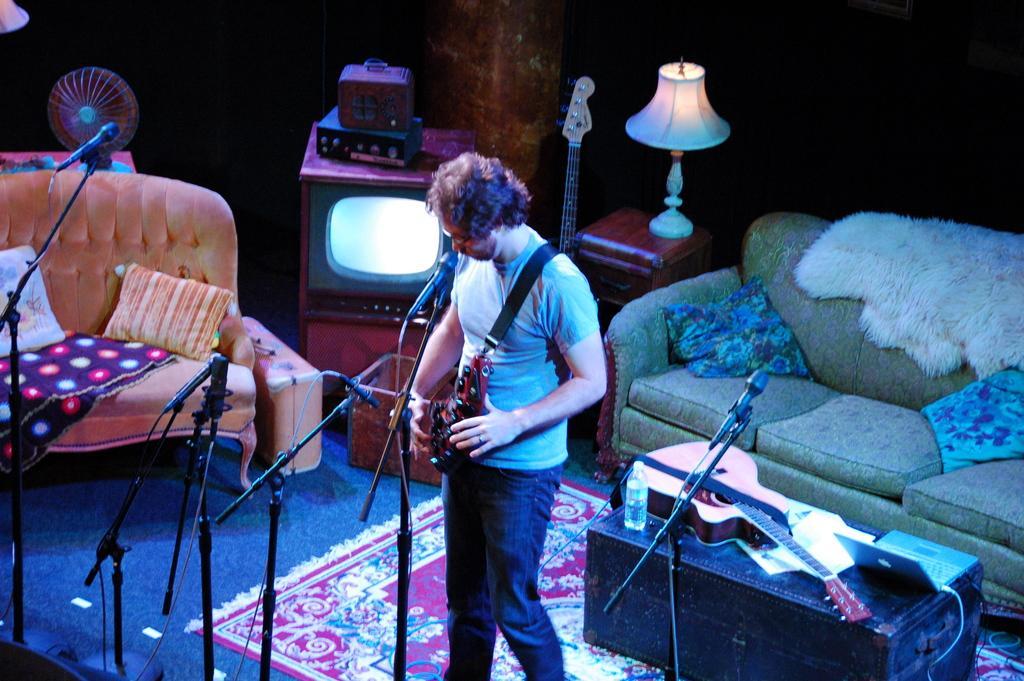Could you give a brief overview of what you see in this image? In this picture there is a Man Standing and playing a musical instrument in front of a microphone and stand. There is a sofa set, fan, television and a lamp placed on a stool here. In the background there is a wall. 